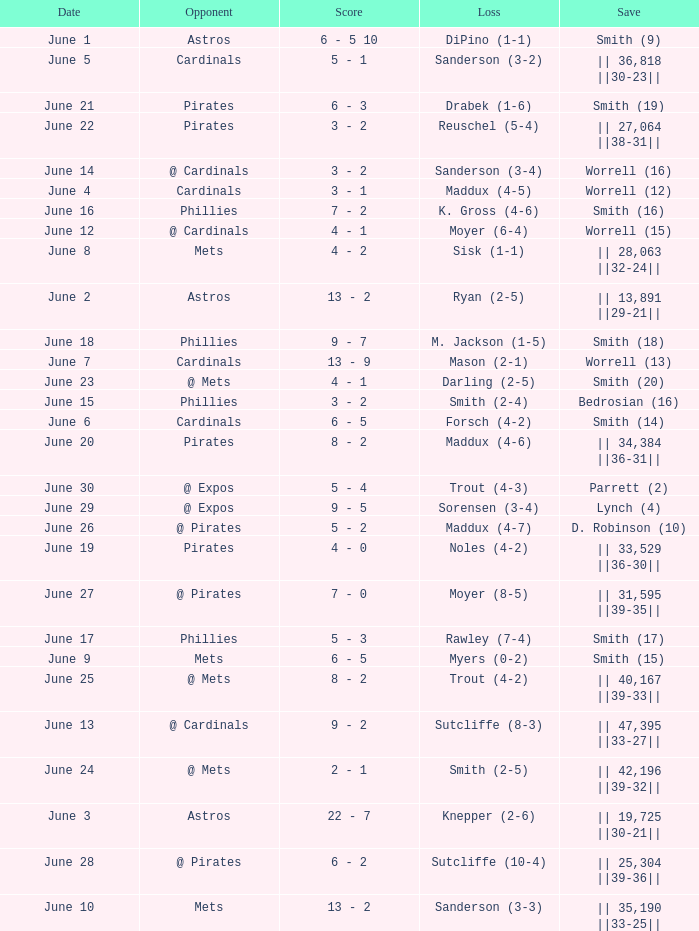The game that has a save of lynch (4) ended with what score? 9 - 5. 